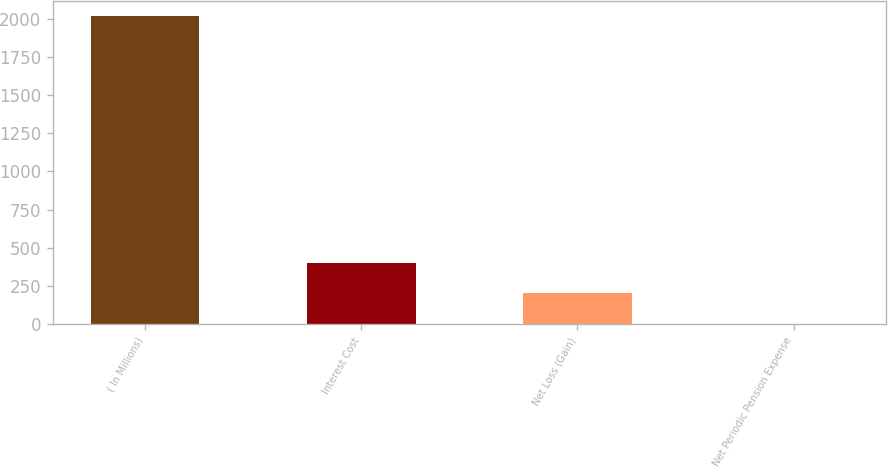Convert chart. <chart><loc_0><loc_0><loc_500><loc_500><bar_chart><fcel>( In Millions)<fcel>Interest Cost<fcel>Net Loss (Gain)<fcel>Net Periodic Pension Expense<nl><fcel>2014<fcel>403.2<fcel>201.85<fcel>0.5<nl></chart> 